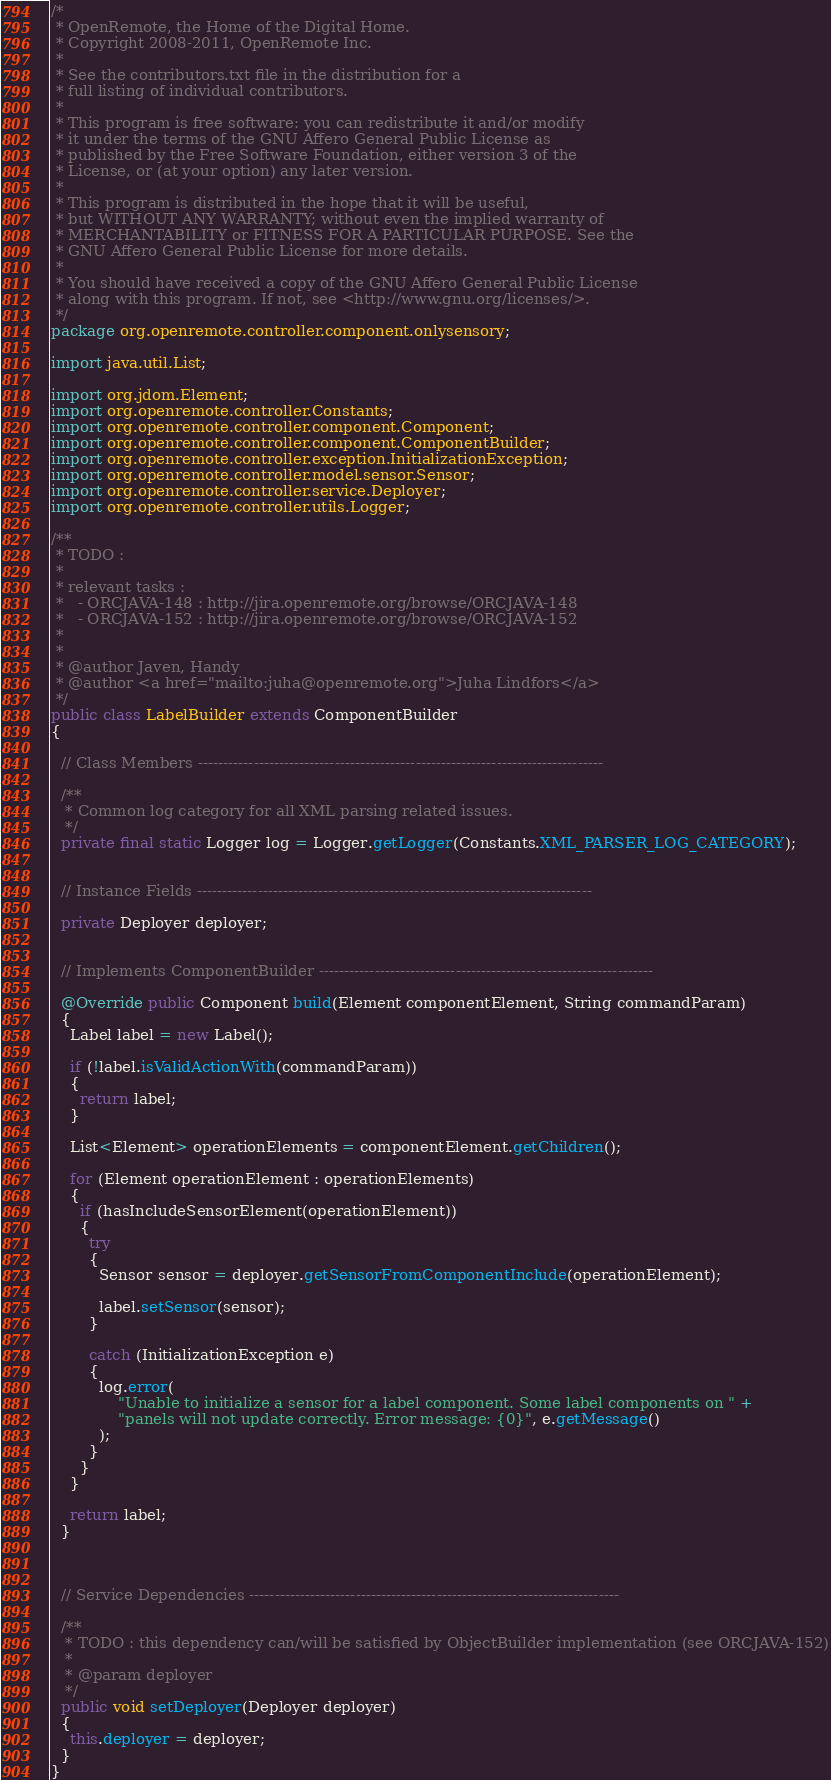<code> <loc_0><loc_0><loc_500><loc_500><_Java_>/*
 * OpenRemote, the Home of the Digital Home.
 * Copyright 2008-2011, OpenRemote Inc.
 *
 * See the contributors.txt file in the distribution for a
 * full listing of individual contributors.
 *
 * This program is free software: you can redistribute it and/or modify
 * it under the terms of the GNU Affero General Public License as
 * published by the Free Software Foundation, either version 3 of the
 * License, or (at your option) any later version.
 *
 * This program is distributed in the hope that it will be useful,
 * but WITHOUT ANY WARRANTY; without even the implied warranty of
 * MERCHANTABILITY or FITNESS FOR A PARTICULAR PURPOSE. See the
 * GNU Affero General Public License for more details.
 *
 * You should have received a copy of the GNU Affero General Public License
 * along with this program. If not, see <http://www.gnu.org/licenses/>.
 */
package org.openremote.controller.component.onlysensory;

import java.util.List;

import org.jdom.Element;
import org.openremote.controller.Constants;
import org.openremote.controller.component.Component;
import org.openremote.controller.component.ComponentBuilder;
import org.openremote.controller.exception.InitializationException;
import org.openremote.controller.model.sensor.Sensor;
import org.openremote.controller.service.Deployer;
import org.openremote.controller.utils.Logger;

/**
 * TODO :
 *
 * relevant tasks :
 *   - ORCJAVA-148 : http://jira.openremote.org/browse/ORCJAVA-148
 *   - ORCJAVA-152 : http://jira.openremote.org/browse/ORCJAVA-152
 *
 *
 * @author Javen, Handy
 * @author <a href="mailto:juha@openremote.org">Juha Lindfors</a>
 */
public class LabelBuilder extends ComponentBuilder
{

  // Class Members --------------------------------------------------------------------------------

  /**
   * Common log category for all XML parsing related issues.
   */
  private final static Logger log = Logger.getLogger(Constants.XML_PARSER_LOG_CATEGORY);


  // Instance Fields ------------------------------------------------------------------------------

  private Deployer deployer;


  // Implements ComponentBuilder ------------------------------------------------------------------

  @Override public Component build(Element componentElement, String commandParam)
  {
    Label label = new Label();

    if (!label.isValidActionWith(commandParam))
    {
      return label;
    }

    List<Element> operationElements = componentElement.getChildren();

    for (Element operationElement : operationElements)
    {
      if (hasIncludeSensorElement(operationElement))
      {
        try
        {
          Sensor sensor = deployer.getSensorFromComponentInclude(operationElement);
          
          label.setSensor(sensor);
        }

        catch (InitializationException e)
        {
          log.error(
              "Unable to initialize a sensor for a label component. Some label components on " +
              "panels will not update correctly. Error message: {0}", e.getMessage()
          );
        }
      }
    }

    return label;
  }



  // Service Dependencies -------------------------------------------------------------------------

  /**
   * TODO : this dependency can/will be satisfied by ObjectBuilder implementation (see ORCJAVA-152)
   *
   * @param deployer
   */
  public void setDeployer(Deployer deployer)
  {
    this.deployer = deployer;
  }
}
</code> 